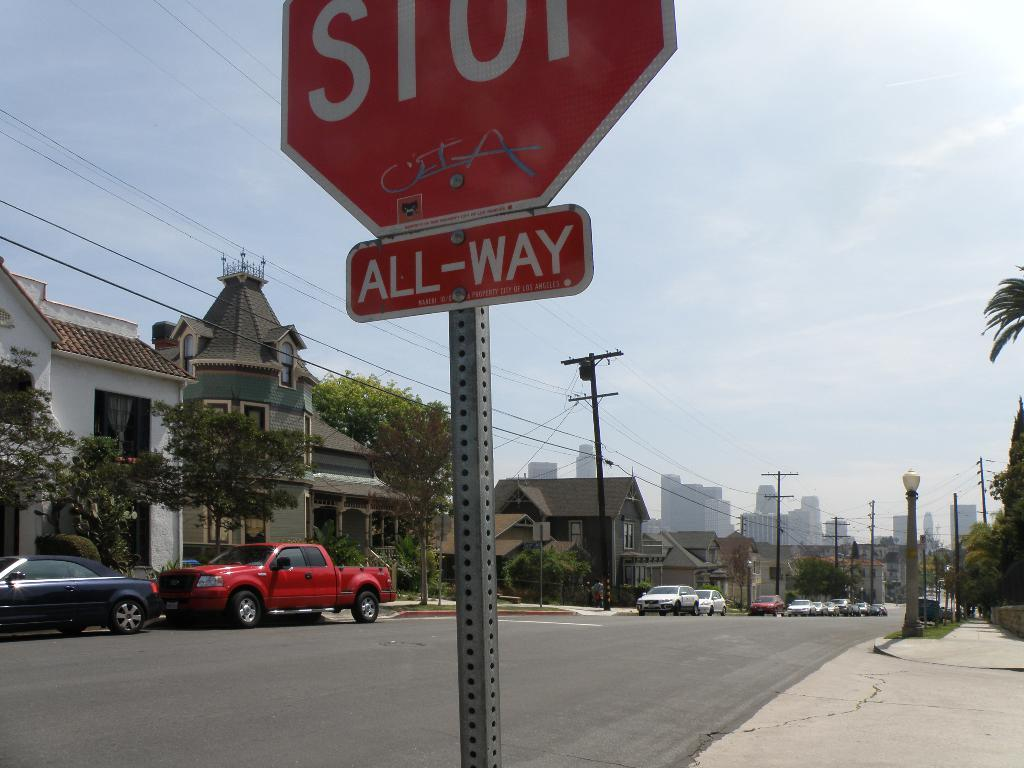<image>
Provide a brief description of the given image. An all-way stop sign is in the foreground of this image of a street with a city in the background. 